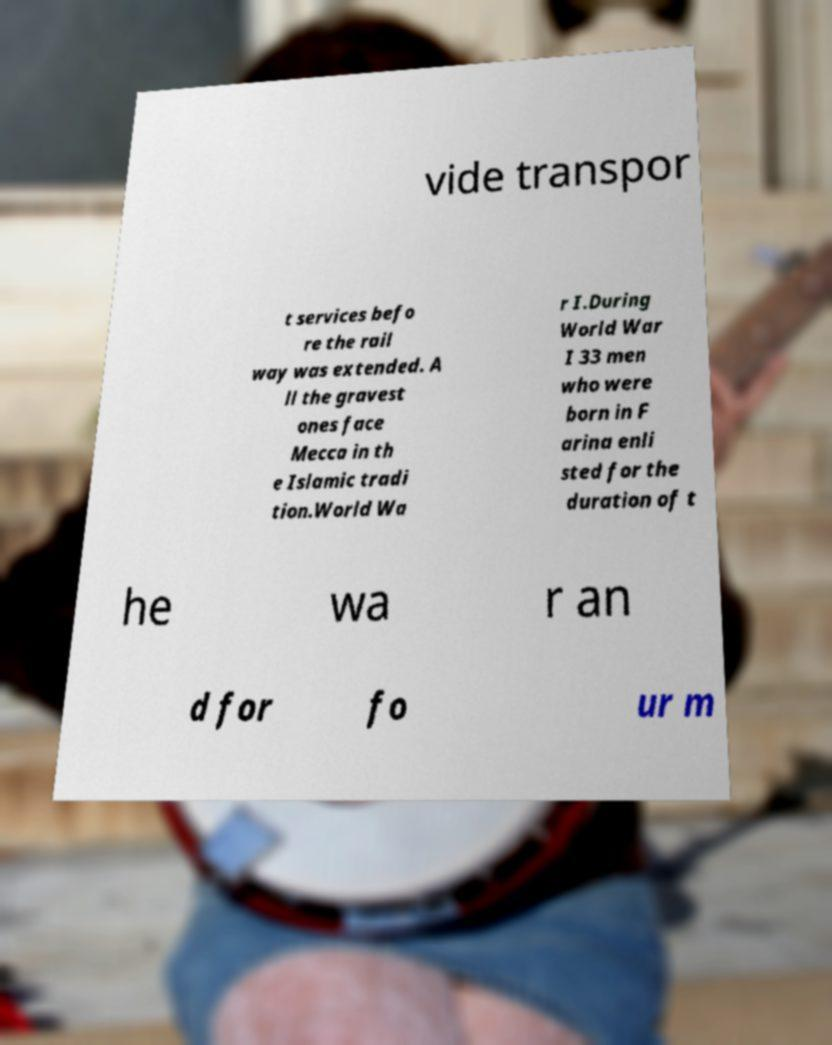There's text embedded in this image that I need extracted. Can you transcribe it verbatim? vide transpor t services befo re the rail way was extended. A ll the gravest ones face Mecca in th e Islamic tradi tion.World Wa r I.During World War I 33 men who were born in F arina enli sted for the duration of t he wa r an d for fo ur m 